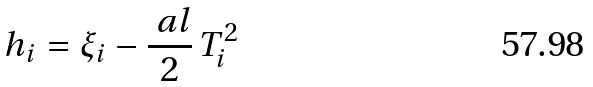Convert formula to latex. <formula><loc_0><loc_0><loc_500><loc_500>h _ { i } = \xi _ { i } - \frac { \ a l } { 2 } \, T _ { i } ^ { 2 }</formula> 